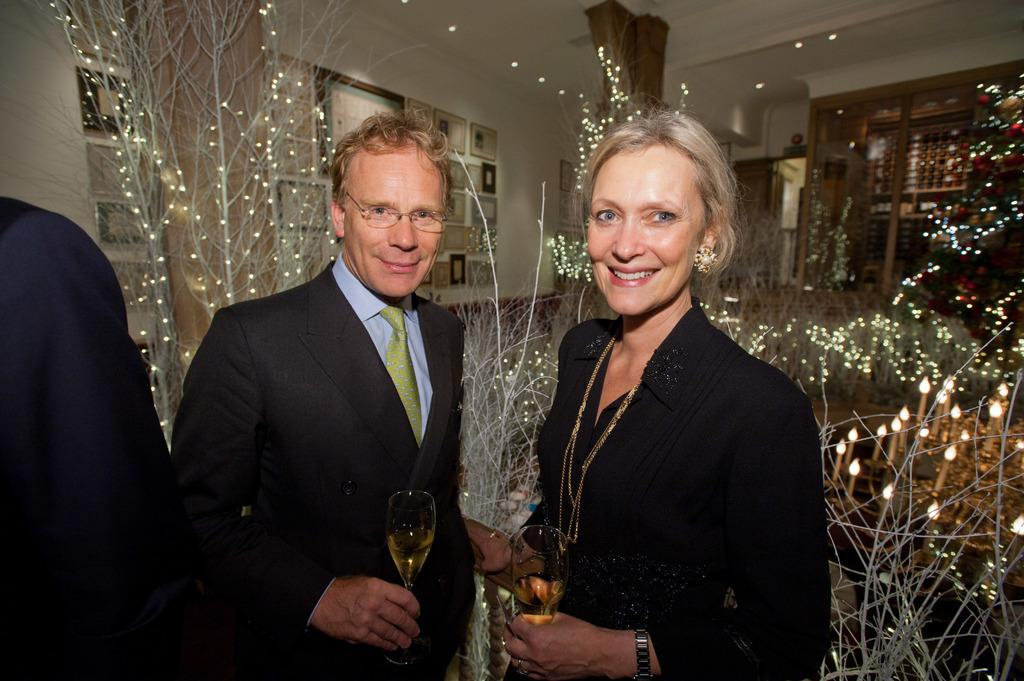How many people are present in the image? There are three people in the image. What are the man and the woman holding in their hands? The man and the woman are holding glasses in their hands. What expressions do the man and the woman have? The man and the woman are smiling. What can be seen in the background of the image? There are lights and frames on the wall in the background of the image. What type of force is being applied to the glasses in the image? There is no indication of any force being applied to the glasses in the image; they are simply being held by the man and the woman. Is there a fire visible in the image? No, there is no fire present in the image. 